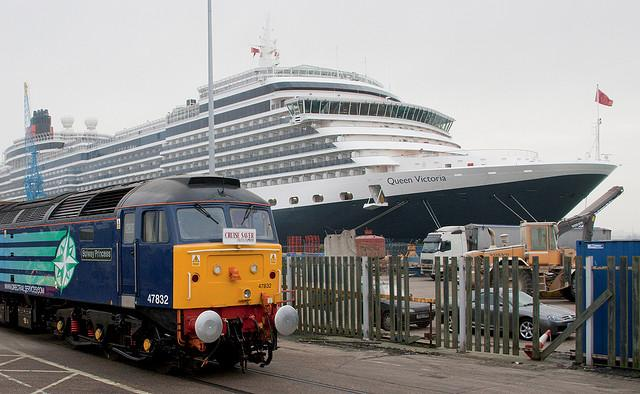The train is parked near what type of body of water? ocean 